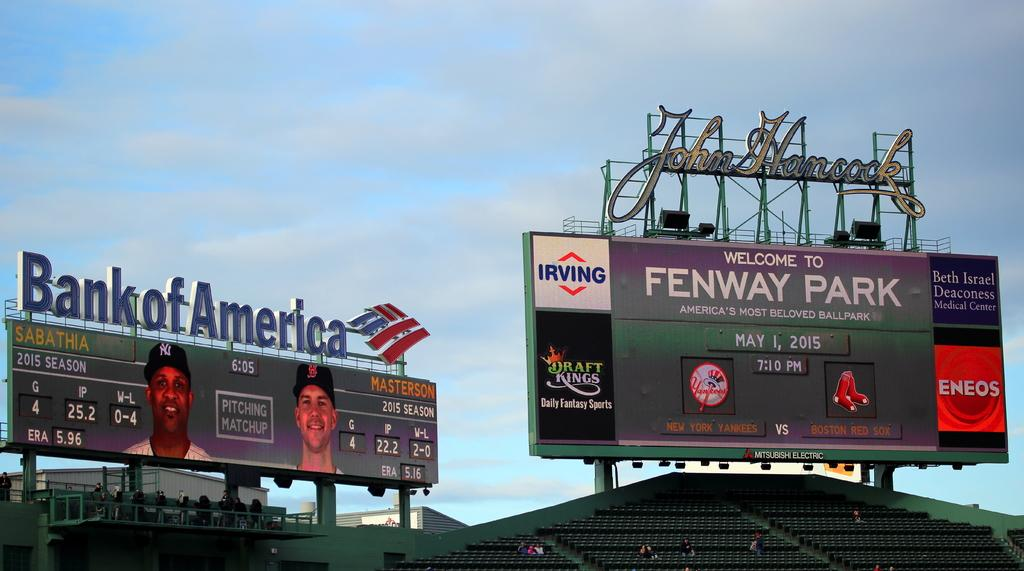Provide a one-sentence caption for the provided image. The signature of John Hancock hangs over a Fenway Park sign. 